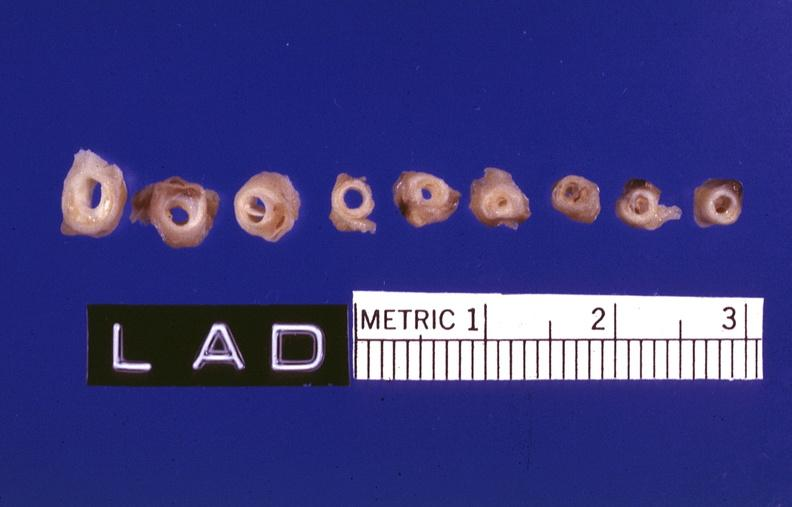what does this image show?
Answer the question using a single word or phrase. Atherosclerosis 